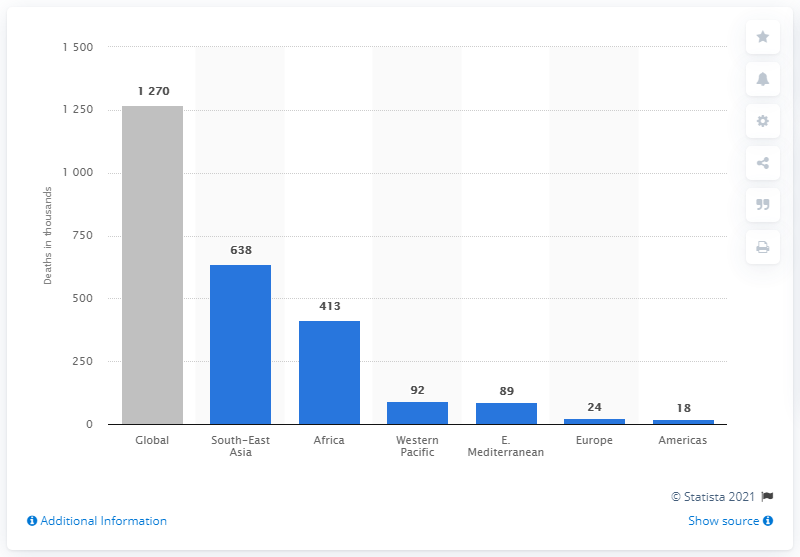Point out several critical features in this image. In 2017, a total of 413 people in Africa lost their lives due to tuberculosis. 